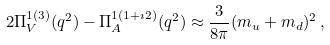Convert formula to latex. <formula><loc_0><loc_0><loc_500><loc_500>2 \Pi _ { V } ^ { 1 ( 3 ) } ( q ^ { 2 } ) - \Pi _ { A } ^ { 1 ( 1 + \imath 2 ) } ( q ^ { 2 } ) \approx \frac { 3 } { 8 \pi } ( m _ { u } + m _ { d } ) ^ { 2 } \, ,</formula> 